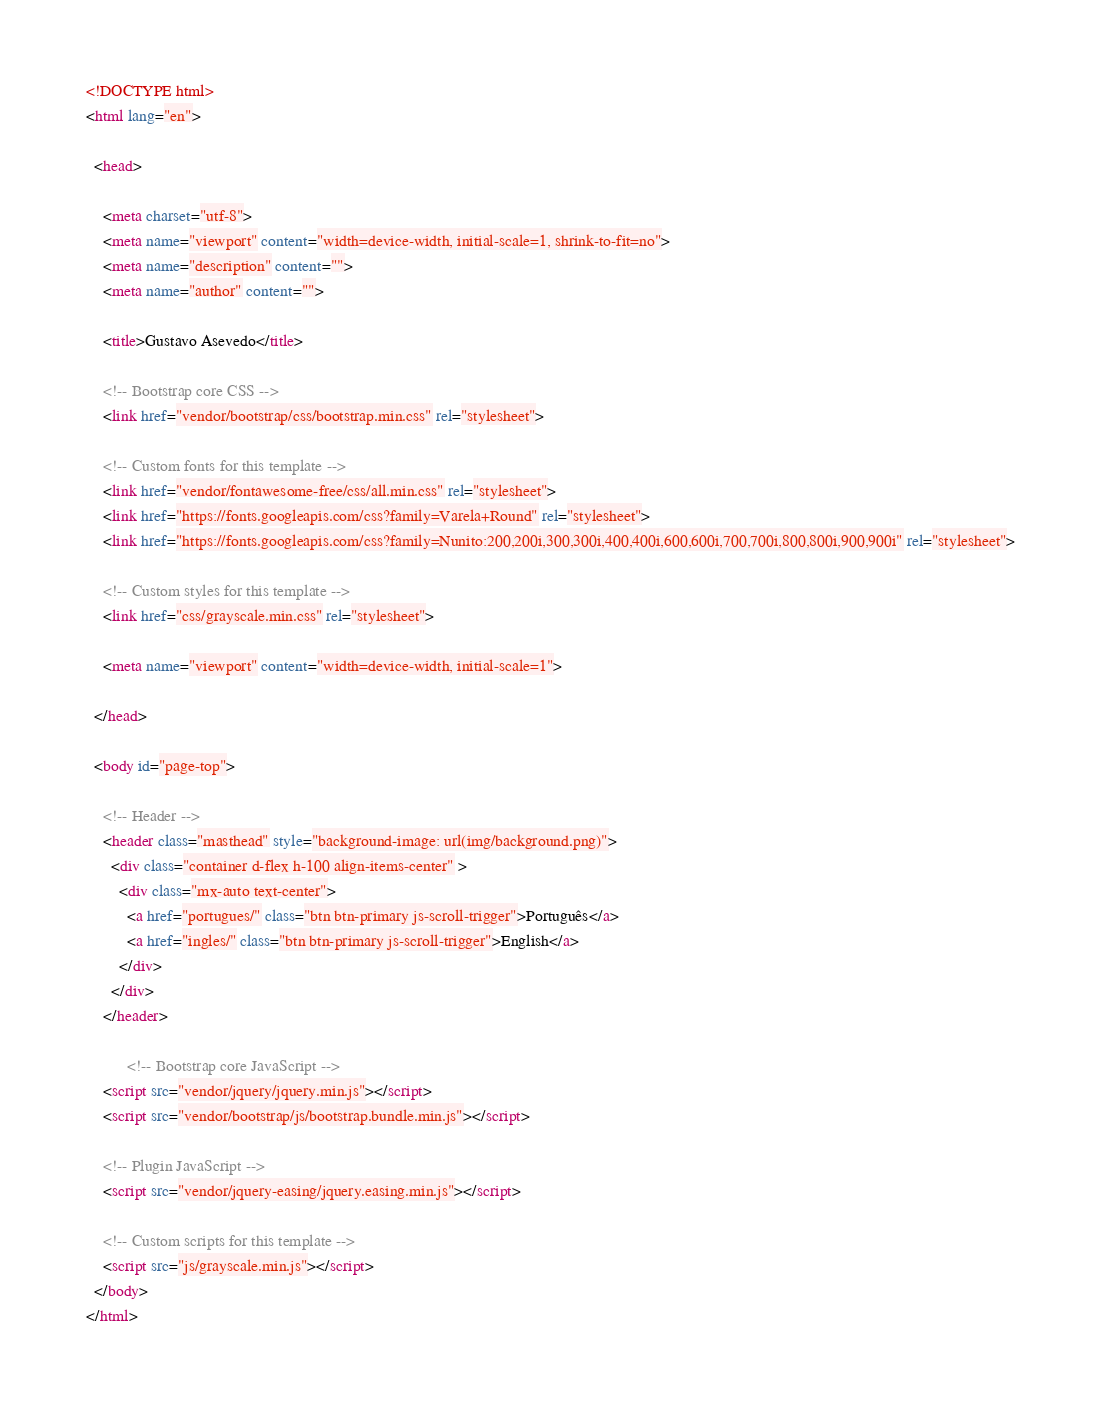Convert code to text. <code><loc_0><loc_0><loc_500><loc_500><_HTML_>  <!DOCTYPE html>
  <html lang="en">

    <head>

      <meta charset="utf-8">
      <meta name="viewport" content="width=device-width, initial-scale=1, shrink-to-fit=no">
      <meta name="description" content="">
      <meta name="author" content="">

      <title>Gustavo Asevedo</title>

      <!-- Bootstrap core CSS -->
      <link href="vendor/bootstrap/css/bootstrap.min.css" rel="stylesheet">

      <!-- Custom fonts for this template -->
      <link href="vendor/fontawesome-free/css/all.min.css" rel="stylesheet">
      <link href="https://fonts.googleapis.com/css?family=Varela+Round" rel="stylesheet">
      <link href="https://fonts.googleapis.com/css?family=Nunito:200,200i,300,300i,400,400i,600,600i,700,700i,800,800i,900,900i" rel="stylesheet">

      <!-- Custom styles for this template -->
      <link href="css/grayscale.min.css" rel="stylesheet">

      <meta name="viewport" content="width=device-width, initial-scale=1">

    </head>

    <body id="page-top">

      <!-- Header -->
      <header class="masthead" style="background-image: url(img/background.png)">
        <div class="container d-flex h-100 align-items-center" >
          <div class="mx-auto text-center">
            <a href="portugues/" class="btn btn-primary js-scroll-trigger">Português</a>
            <a href="ingles/" class="btn btn-primary js-scroll-trigger">English</a>
          </div>
        </div>
      </header>

            <!-- Bootstrap core JavaScript -->
      <script src="vendor/jquery/jquery.min.js"></script>
      <script src="vendor/bootstrap/js/bootstrap.bundle.min.js"></script>

      <!-- Plugin JavaScript -->
      <script src="vendor/jquery-easing/jquery.easing.min.js"></script>

      <!-- Custom scripts for this template -->
      <script src="js/grayscale.min.js"></script>
    </body>
  </html></code> 